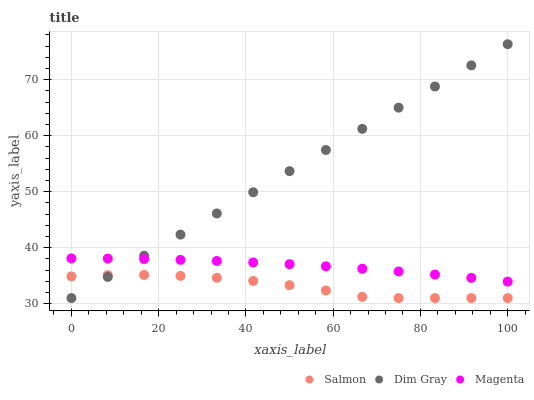Does Salmon have the minimum area under the curve?
Answer yes or no. Yes. Does Dim Gray have the maximum area under the curve?
Answer yes or no. Yes. Does Dim Gray have the minimum area under the curve?
Answer yes or no. No. Does Salmon have the maximum area under the curve?
Answer yes or no. No. Is Dim Gray the smoothest?
Answer yes or no. Yes. Is Salmon the roughest?
Answer yes or no. Yes. Is Salmon the smoothest?
Answer yes or no. No. Is Dim Gray the roughest?
Answer yes or no. No. Does Dim Gray have the lowest value?
Answer yes or no. Yes. Does Dim Gray have the highest value?
Answer yes or no. Yes. Does Salmon have the highest value?
Answer yes or no. No. Is Salmon less than Magenta?
Answer yes or no. Yes. Is Magenta greater than Salmon?
Answer yes or no. Yes. Does Dim Gray intersect Salmon?
Answer yes or no. Yes. Is Dim Gray less than Salmon?
Answer yes or no. No. Is Dim Gray greater than Salmon?
Answer yes or no. No. Does Salmon intersect Magenta?
Answer yes or no. No. 